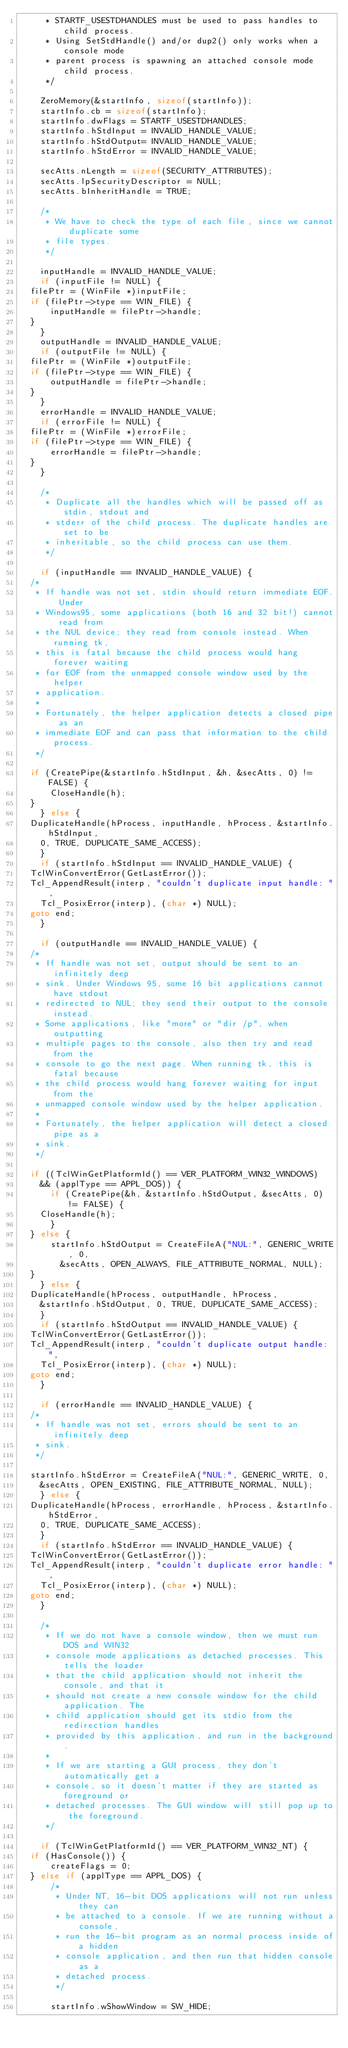<code> <loc_0><loc_0><loc_500><loc_500><_C_>     * STARTF_USESTDHANDLES must be used to pass handles to child process.
     * Using SetStdHandle() and/or dup2() only works when a console mode
     * parent process is spawning an attached console mode child process.
     */

    ZeroMemory(&startInfo, sizeof(startInfo));
    startInfo.cb = sizeof(startInfo);
    startInfo.dwFlags	= STARTF_USESTDHANDLES;
    startInfo.hStdInput	= INVALID_HANDLE_VALUE;
    startInfo.hStdOutput= INVALID_HANDLE_VALUE;
    startInfo.hStdError = INVALID_HANDLE_VALUE;

    secAtts.nLength = sizeof(SECURITY_ATTRIBUTES);
    secAtts.lpSecurityDescriptor = NULL;
    secAtts.bInheritHandle = TRUE;

    /*
     * We have to check the type of each file, since we cannot duplicate some
     * file types.
     */

    inputHandle = INVALID_HANDLE_VALUE;
    if (inputFile != NULL) {
	filePtr = (WinFile *)inputFile;
	if (filePtr->type == WIN_FILE) {
	    inputHandle = filePtr->handle;
	}
    }
    outputHandle = INVALID_HANDLE_VALUE;
    if (outputFile != NULL) {
	filePtr = (WinFile *)outputFile;
	if (filePtr->type == WIN_FILE) {
	    outputHandle = filePtr->handle;
	}
    }
    errorHandle = INVALID_HANDLE_VALUE;
    if (errorFile != NULL) {
	filePtr = (WinFile *)errorFile;
	if (filePtr->type == WIN_FILE) {
	    errorHandle = filePtr->handle;
	}
    }

    /*
     * Duplicate all the handles which will be passed off as stdin, stdout and
     * stderr of the child process. The duplicate handles are set to be
     * inheritable, so the child process can use them.
     */

    if (inputHandle == INVALID_HANDLE_VALUE) {
	/*
	 * If handle was not set, stdin should return immediate EOF. Under
	 * Windows95, some applications (both 16 and 32 bit!) cannot read from
	 * the NUL device; they read from console instead. When running tk,
	 * this is fatal because the child process would hang forever waiting
	 * for EOF from the unmapped console window used by the helper
	 * application.
	 *
	 * Fortunately, the helper application detects a closed pipe as an
	 * immediate EOF and can pass that information to the child process.
	 */

	if (CreatePipe(&startInfo.hStdInput, &h, &secAtts, 0) != FALSE) {
	    CloseHandle(h);
	}
    } else {
	DuplicateHandle(hProcess, inputHandle, hProcess, &startInfo.hStdInput,
		0, TRUE, DUPLICATE_SAME_ACCESS);
    }
    if (startInfo.hStdInput == INVALID_HANDLE_VALUE) {
	TclWinConvertError(GetLastError());
	Tcl_AppendResult(interp, "couldn't duplicate input handle: ",
		Tcl_PosixError(interp), (char *) NULL);
	goto end;
    }

    if (outputHandle == INVALID_HANDLE_VALUE) {
	/*
	 * If handle was not set, output should be sent to an infinitely deep
	 * sink. Under Windows 95, some 16 bit applications cannot have stdout
	 * redirected to NUL; they send their output to the console instead.
	 * Some applications, like "more" or "dir /p", when outputting
	 * multiple pages to the console, also then try and read from the
	 * console to go the next page. When running tk, this is fatal because
	 * the child process would hang forever waiting for input from the
	 * unmapped console window used by the helper application.
	 *
	 * Fortunately, the helper application will detect a closed pipe as a
	 * sink.
	 */

	if ((TclWinGetPlatformId() == VER_PLATFORM_WIN32_WINDOWS)
		&& (applType == APPL_DOS)) {
	    if (CreatePipe(&h, &startInfo.hStdOutput, &secAtts, 0) != FALSE) {
		CloseHandle(h);
	    }
	} else {
	    startInfo.hStdOutput = CreateFileA("NUL:", GENERIC_WRITE, 0,
		    &secAtts, OPEN_ALWAYS, FILE_ATTRIBUTE_NORMAL, NULL);
	}
    } else {
	DuplicateHandle(hProcess, outputHandle, hProcess,
		&startInfo.hStdOutput, 0, TRUE, DUPLICATE_SAME_ACCESS);
    }
    if (startInfo.hStdOutput == INVALID_HANDLE_VALUE) {
	TclWinConvertError(GetLastError());
	Tcl_AppendResult(interp, "couldn't duplicate output handle: ",
		Tcl_PosixError(interp), (char *) NULL);
	goto end;
    }

    if (errorHandle == INVALID_HANDLE_VALUE) {
	/*
	 * If handle was not set, errors should be sent to an infinitely deep
	 * sink.
	 */

	startInfo.hStdError = CreateFileA("NUL:", GENERIC_WRITE, 0,
		&secAtts, OPEN_EXISTING, FILE_ATTRIBUTE_NORMAL, NULL);
    } else {
	DuplicateHandle(hProcess, errorHandle, hProcess, &startInfo.hStdError,
		0, TRUE, DUPLICATE_SAME_ACCESS);
    }
    if (startInfo.hStdError == INVALID_HANDLE_VALUE) {
	TclWinConvertError(GetLastError());
	Tcl_AppendResult(interp, "couldn't duplicate error handle: ",
		Tcl_PosixError(interp), (char *) NULL);
	goto end;
    }

    /*
     * If we do not have a console window, then we must run DOS and WIN32
     * console mode applications as detached processes. This tells the loader
     * that the child application should not inherit the console, and that it
     * should not create a new console window for the child application. The
     * child application should get its stdio from the redirection handles
     * provided by this application, and run in the background.
     *
     * If we are starting a GUI process, they don't automatically get a
     * console, so it doesn't matter if they are started as foreground or
     * detached processes. The GUI window will still pop up to the foreground.
     */

    if (TclWinGetPlatformId() == VER_PLATFORM_WIN32_NT) {
	if (HasConsole()) {
	    createFlags = 0;
	} else if (applType == APPL_DOS) {
	    /*
	     * Under NT, 16-bit DOS applications will not run unless they can
	     * be attached to a console. If we are running without a console,
	     * run the 16-bit program as an normal process inside of a hidden
	     * console application, and then run that hidden console as a
	     * detached process.
	     */

	    startInfo.wShowWindow = SW_HIDE;</code> 